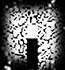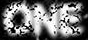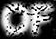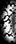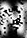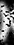Identify the words shown in these images in order, separated by a semicolon. .; ONE; OF; (; N; ) 